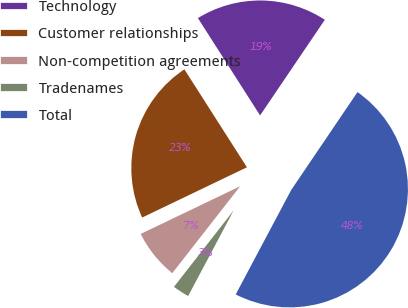<chart> <loc_0><loc_0><loc_500><loc_500><pie_chart><fcel>Technology<fcel>Customer relationships<fcel>Non-competition agreements<fcel>Tradenames<fcel>Total<nl><fcel>18.52%<fcel>23.07%<fcel>7.33%<fcel>2.78%<fcel>48.3%<nl></chart> 